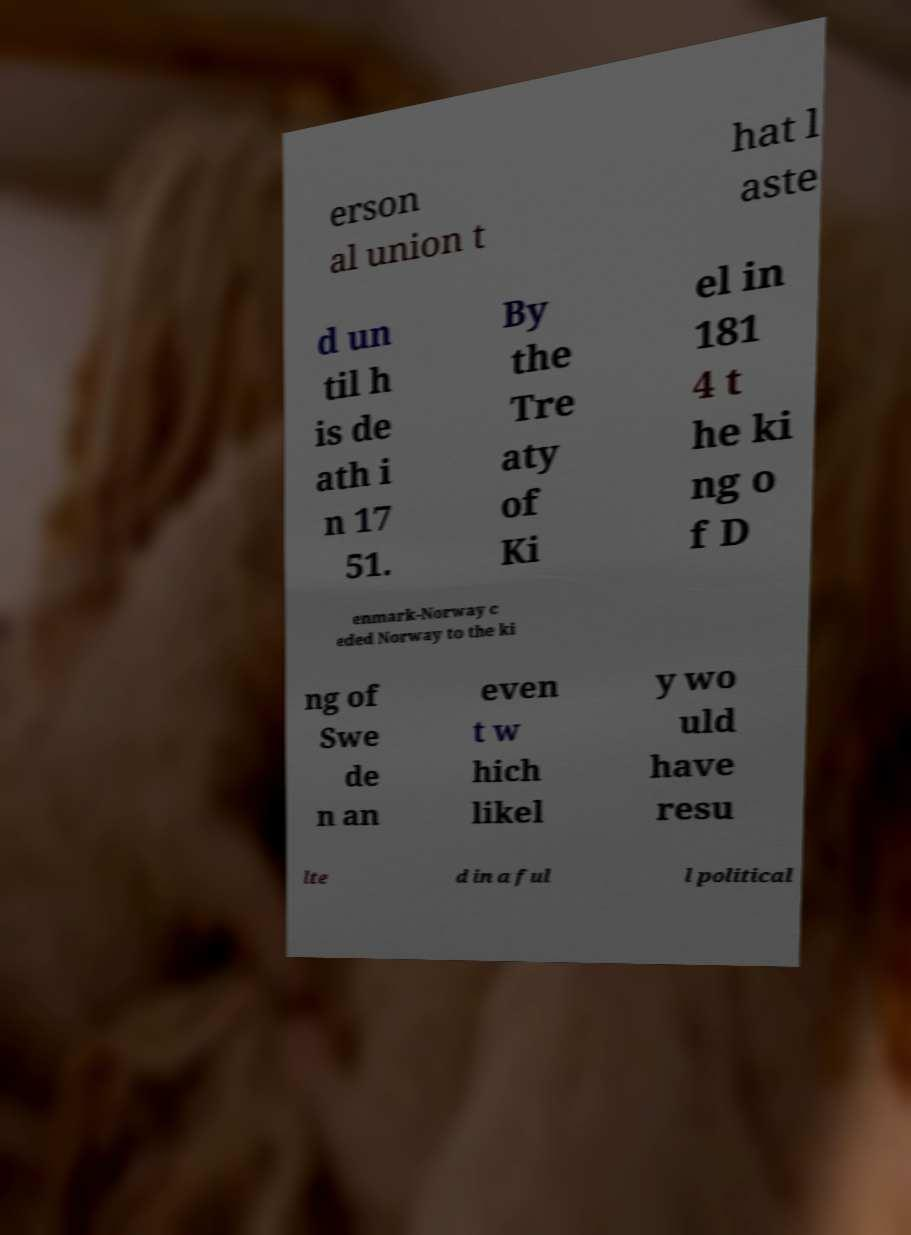Could you extract and type out the text from this image? erson al union t hat l aste d un til h is de ath i n 17 51. By the Tre aty of Ki el in 181 4 t he ki ng o f D enmark-Norway c eded Norway to the ki ng of Swe de n an even t w hich likel y wo uld have resu lte d in a ful l political 